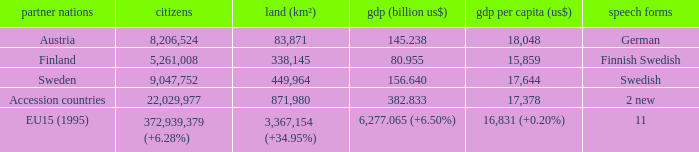Name the population for 11 languages 372,939,379 (+6.28%). 